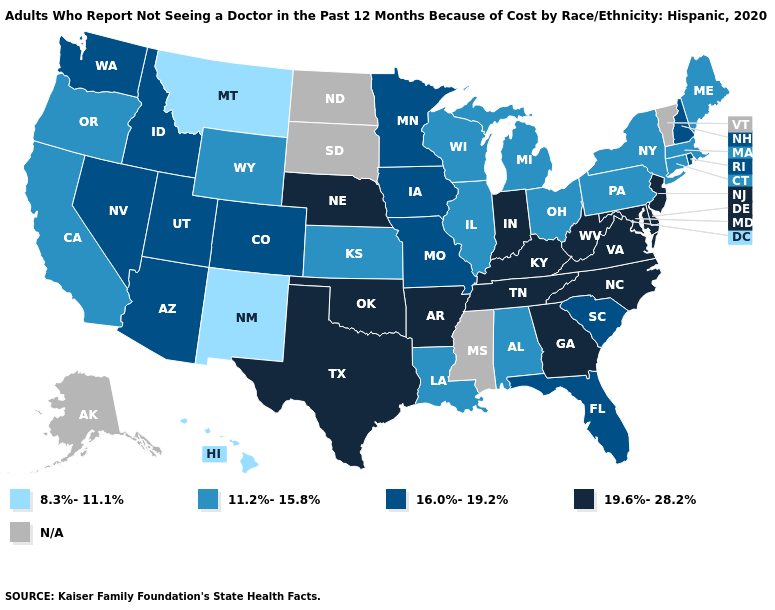What is the value of Arizona?
Keep it brief. 16.0%-19.2%. Among the states that border Pennsylvania , does New York have the highest value?
Concise answer only. No. Among the states that border Arkansas , does Texas have the highest value?
Keep it brief. Yes. What is the lowest value in states that border Montana?
Write a very short answer. 11.2%-15.8%. Does Missouri have the lowest value in the MidWest?
Answer briefly. No. Which states have the lowest value in the USA?
Short answer required. Hawaii, Montana, New Mexico. Name the states that have a value in the range 16.0%-19.2%?
Short answer required. Arizona, Colorado, Florida, Idaho, Iowa, Minnesota, Missouri, Nevada, New Hampshire, Rhode Island, South Carolina, Utah, Washington. What is the value of New Hampshire?
Answer briefly. 16.0%-19.2%. What is the highest value in states that border Florida?
Give a very brief answer. 19.6%-28.2%. Name the states that have a value in the range 19.6%-28.2%?
Write a very short answer. Arkansas, Delaware, Georgia, Indiana, Kentucky, Maryland, Nebraska, New Jersey, North Carolina, Oklahoma, Tennessee, Texas, Virginia, West Virginia. Does the map have missing data?
Quick response, please. Yes. What is the highest value in the West ?
Be succinct. 16.0%-19.2%. Does Nevada have the lowest value in the West?
Short answer required. No. 